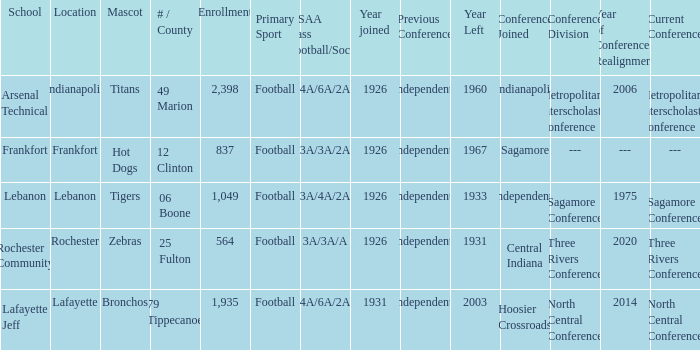What is the lowest enrollment that has Lafayette as the location? 1935.0. 